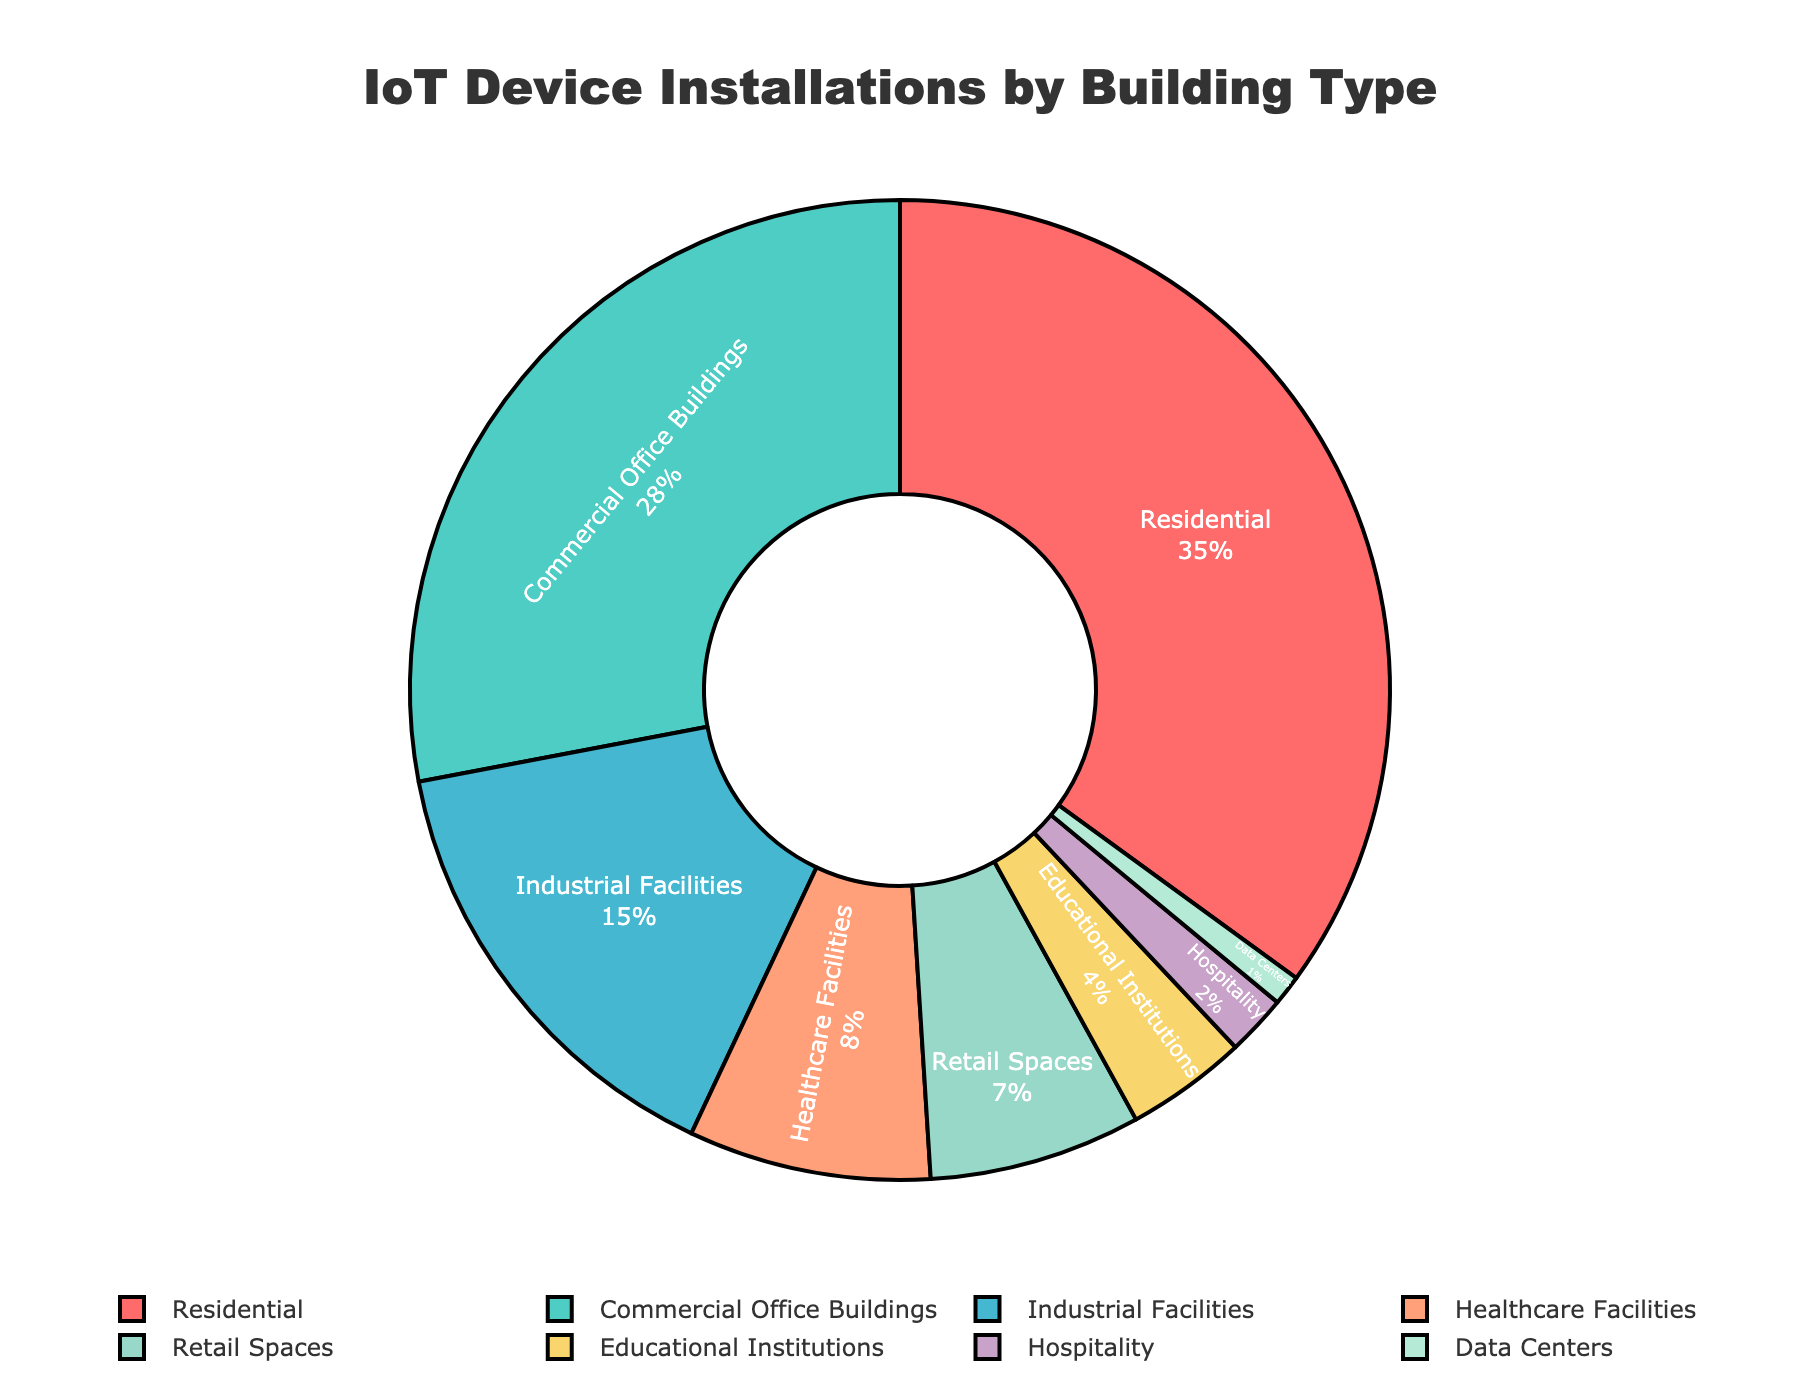what is the percentage contribution of Commercial Office Buildings and Retail Spaces combined? First, we locate the percentage values for Commercial Office Buildings (28%) and Retail Spaces (7%) on the pie chart. Adding these percentages together gives us 28 + 7 = 35.
Answer: 35% Which building type has the lowest percentage of IoT device installations? By observing the pie chart, the building type with the smallest section is Data Centers with 1%.
Answer: Data Centers How much more percentage do Residential buildings have compared to Healthcare Facilities? We find the percentages for Residential buildings (35%) and Healthcare Facilities (8%) on the pie chart. Subtracting these values gives us 35 - 8 = 27.
Answer: 27% Which sector has a higher percentage of installations, Industrial Facilities or Educational Institutions? Comparing the percentages, Industrial Facilities have 15% and Educational Institutions have 4%. Industrial Facilities have a higher percentage.
Answer: Industrial Facilities What is the color representing Hospitality in the pie chart? By examining the colors associated with the labels, Hospitality is represented by the purple color.
Answer: Purple What percentage of IoT device installations is accommodated by non-residential buildings? Summing the percentages of all non-residential buildings (Commercial Office Buildings (28) + Industrial Facilities (15) + Healthcare Facilities (8) + Retail Spaces (7) + Educational Institutions (4) + Hospitality (2) + Data Centers (1)) gives us 65.
Answer: 65% Are there more IoT device installations in Retail Spaces or Hospitality? Observing the chart, Retail Spaces account for 7%, while Hospitality accounts for 2%. Retail Spaces have more installations.
Answer: Retail Spaces If you combine the percentages from Healthcare Facilities and Residential buildings, what fraction of the total does it represent in the simplest form? Adding the percentages of Healthcare Facilities (8) and Residential buildings (35) gives us 43%. To simplify the fraction, divide both numerator and denominator by the greatest common divisor (1). So, 43/100 in simplest form is 43/100.
Answer: 43/100 What combined percentage do Industrial Facilities, Hospitality, and Data Centers represent? Summing the percentages of Industrial Facilities (15%), Hospitality (2%), and Data Centers (1%) gives us 15 + 2 + 1 = 18%.
Answer: 18% Between Educational Institutions and Industrial Facilities, which has a lower percentage of IoT device installations? Comparing the percentages directly from the figure, Educational Institutions have 4% and Industrial Facilities have 15%. Educational Institutions have a lower percentage.
Answer: Educational Institutions 